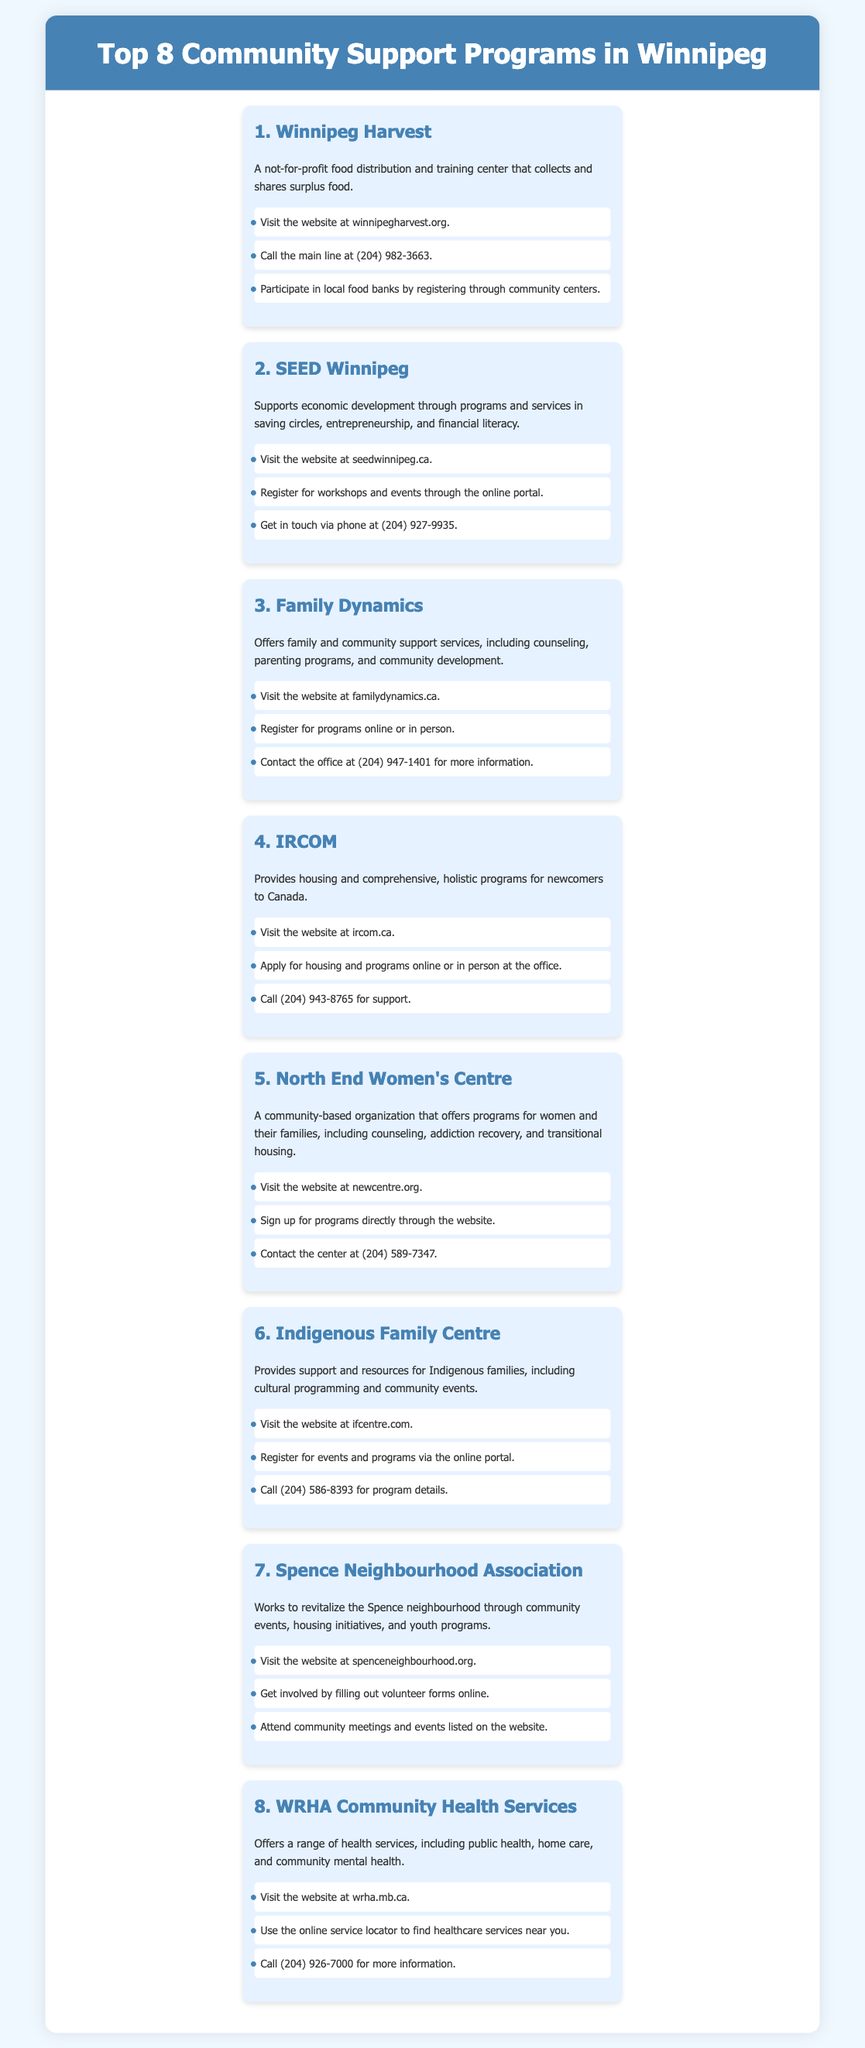What is the primary service provided by Winnipeg Harvest? Winnipeg Harvest is a not-for-profit food distribution and training center that collects and shares surplus food.
Answer: Food distribution How many community support programs are listed in the infographic? The infographic presents a total of eight community support programs available in Winnipeg.
Answer: 8 What is the website for SEED Winnipeg? SEED Winnipeg can be accessed at the website seedwinnipeg.ca.
Answer: seedwinnipeg.ca Which program provides support and resources for Indigenous families? The Indigenous Family Centre provides support and resources for Indigenous families, including cultural programming and community events.
Answer: Indigenous Family Centre What phone number can you dial for information about WRHA Community Health Services? For WRHA Community Health Services, the contact number is (204) 926-7000.
Answer: (204) 926-7000 Which program focuses on economic development and financial literacy? SEED Winnipeg focuses on economic development through programs and services in saving circles, entrepreneurship, and financial literacy.
Answer: SEED Winnipeg Where can you apply for housing programs related to IRCOM? Housing programs for IRCOM can be applied for online or in person at the office.
Answer: Online or in person at the office What kind of events does the Spence Neighbourhood Association organize? The Spence Neighbourhood Association organizes community events, housing initiatives, and youth programs.
Answer: Community events 